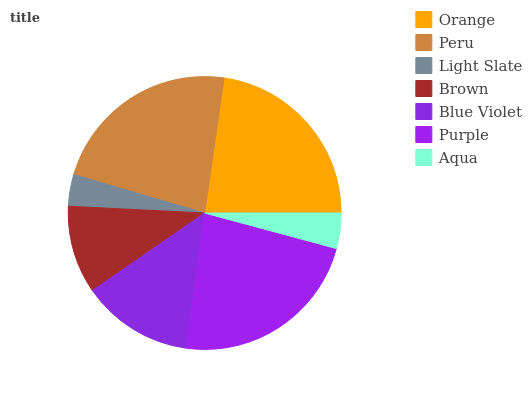Is Light Slate the minimum?
Answer yes or no. Yes. Is Purple the maximum?
Answer yes or no. Yes. Is Peru the minimum?
Answer yes or no. No. Is Peru the maximum?
Answer yes or no. No. Is Peru greater than Orange?
Answer yes or no. Yes. Is Orange less than Peru?
Answer yes or no. Yes. Is Orange greater than Peru?
Answer yes or no. No. Is Peru less than Orange?
Answer yes or no. No. Is Blue Violet the high median?
Answer yes or no. Yes. Is Blue Violet the low median?
Answer yes or no. Yes. Is Orange the high median?
Answer yes or no. No. Is Peru the low median?
Answer yes or no. No. 